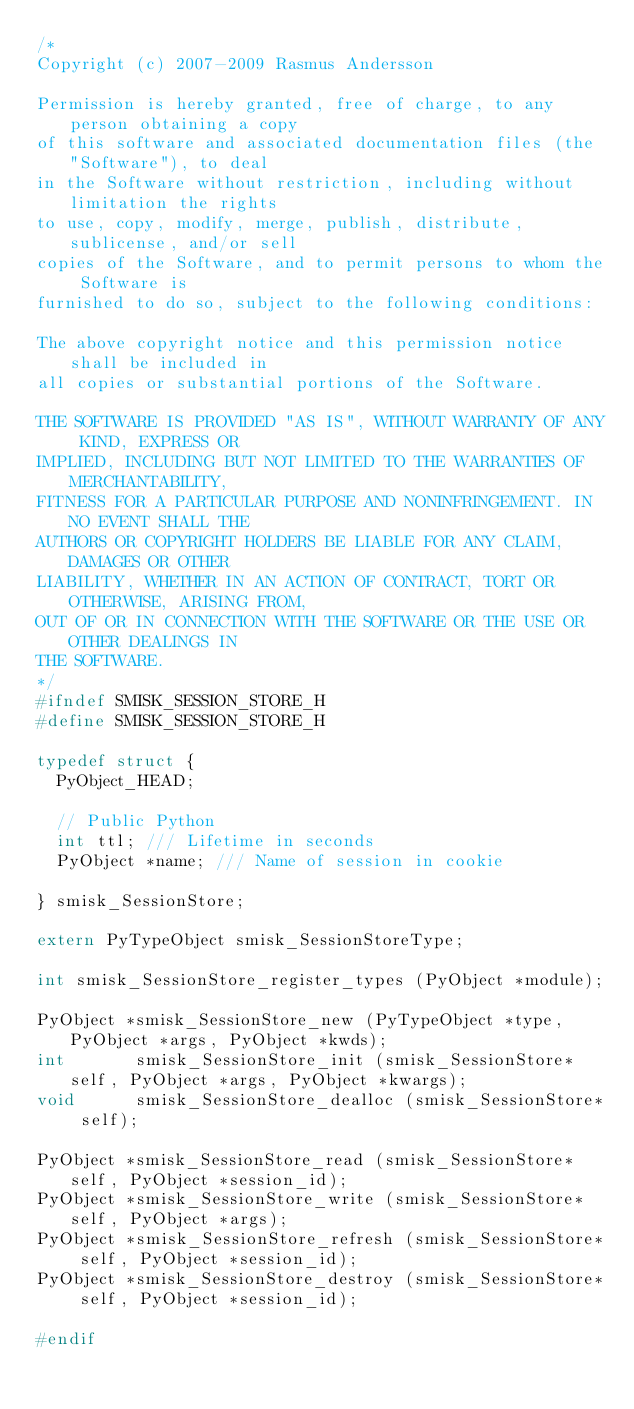Convert code to text. <code><loc_0><loc_0><loc_500><loc_500><_C_>/*
Copyright (c) 2007-2009 Rasmus Andersson

Permission is hereby granted, free of charge, to any person obtaining a copy
of this software and associated documentation files (the "Software"), to deal
in the Software without restriction, including without limitation the rights
to use, copy, modify, merge, publish, distribute, sublicense, and/or sell
copies of the Software, and to permit persons to whom the Software is
furnished to do so, subject to the following conditions:

The above copyright notice and this permission notice shall be included in
all copies or substantial portions of the Software.

THE SOFTWARE IS PROVIDED "AS IS", WITHOUT WARRANTY OF ANY KIND, EXPRESS OR
IMPLIED, INCLUDING BUT NOT LIMITED TO THE WARRANTIES OF MERCHANTABILITY,
FITNESS FOR A PARTICULAR PURPOSE AND NONINFRINGEMENT. IN NO EVENT SHALL THE
AUTHORS OR COPYRIGHT HOLDERS BE LIABLE FOR ANY CLAIM, DAMAGES OR OTHER
LIABILITY, WHETHER IN AN ACTION OF CONTRACT, TORT OR OTHERWISE, ARISING FROM,
OUT OF OR IN CONNECTION WITH THE SOFTWARE OR THE USE OR OTHER DEALINGS IN
THE SOFTWARE.
*/
#ifndef SMISK_SESSION_STORE_H
#define SMISK_SESSION_STORE_H

typedef struct {
  PyObject_HEAD;
  
  // Public Python
  int ttl; /// Lifetime in seconds
  PyObject *name; /// Name of session in cookie
  
} smisk_SessionStore;

extern PyTypeObject smisk_SessionStoreType;

int smisk_SessionStore_register_types (PyObject *module);

PyObject *smisk_SessionStore_new (PyTypeObject *type, PyObject *args, PyObject *kwds);
int       smisk_SessionStore_init (smisk_SessionStore* self, PyObject *args, PyObject *kwargs);
void      smisk_SessionStore_dealloc (smisk_SessionStore* self);

PyObject *smisk_SessionStore_read (smisk_SessionStore* self, PyObject *session_id);
PyObject *smisk_SessionStore_write (smisk_SessionStore* self, PyObject *args);
PyObject *smisk_SessionStore_refresh (smisk_SessionStore* self, PyObject *session_id);
PyObject *smisk_SessionStore_destroy (smisk_SessionStore* self, PyObject *session_id);

#endif
</code> 